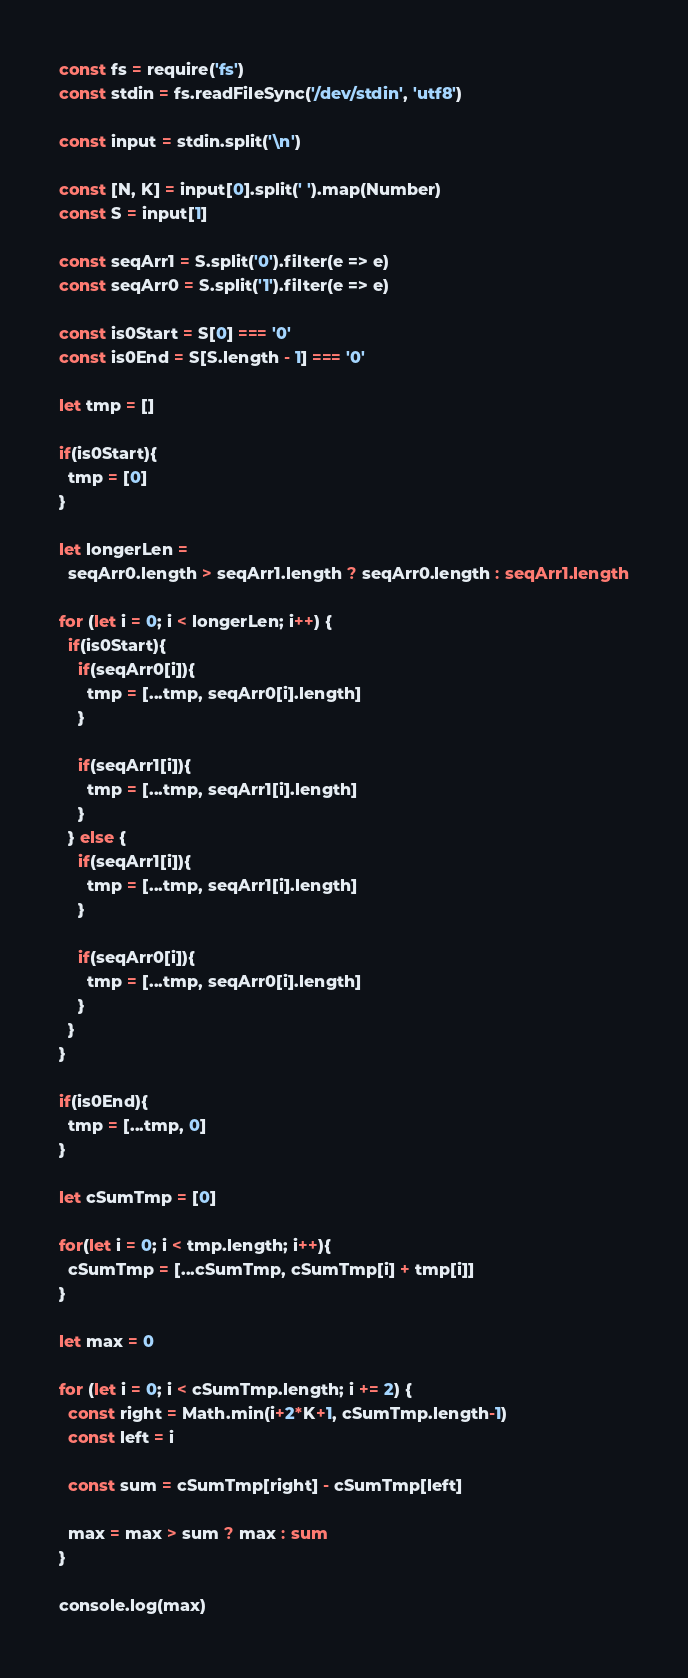<code> <loc_0><loc_0><loc_500><loc_500><_TypeScript_>const fs = require('fs')
const stdin = fs.readFileSync('/dev/stdin', 'utf8')

const input = stdin.split('\n')

const [N, K] = input[0].split(' ').map(Number)
const S = input[1]

const seqArr1 = S.split('0').filter(e => e)
const seqArr0 = S.split('1').filter(e => e)

const is0Start = S[0] === '0'
const is0End = S[S.length - 1] === '0'

let tmp = []

if(is0Start){
  tmp = [0]
}

let longerLen =
  seqArr0.length > seqArr1.length ? seqArr0.length : seqArr1.length

for (let i = 0; i < longerLen; i++) {
  if(is0Start){
    if(seqArr0[i]){
      tmp = [...tmp, seqArr0[i].length]
    }

    if(seqArr1[i]){
      tmp = [...tmp, seqArr1[i].length]
    }
  } else {
    if(seqArr1[i]){
      tmp = [...tmp, seqArr1[i].length]
    }

    if(seqArr0[i]){
      tmp = [...tmp, seqArr0[i].length]
    }
  }
}

if(is0End){
  tmp = [...tmp, 0]
}

let cSumTmp = [0]

for(let i = 0; i < tmp.length; i++){
  cSumTmp = [...cSumTmp, cSumTmp[i] + tmp[i]]
}

let max = 0

for (let i = 0; i < cSumTmp.length; i += 2) {
  const right = Math.min(i+2*K+1, cSumTmp.length-1)
  const left = i
  
  const sum = cSumTmp[right] - cSumTmp[left]

  max = max > sum ? max : sum
}

console.log(max)
</code> 